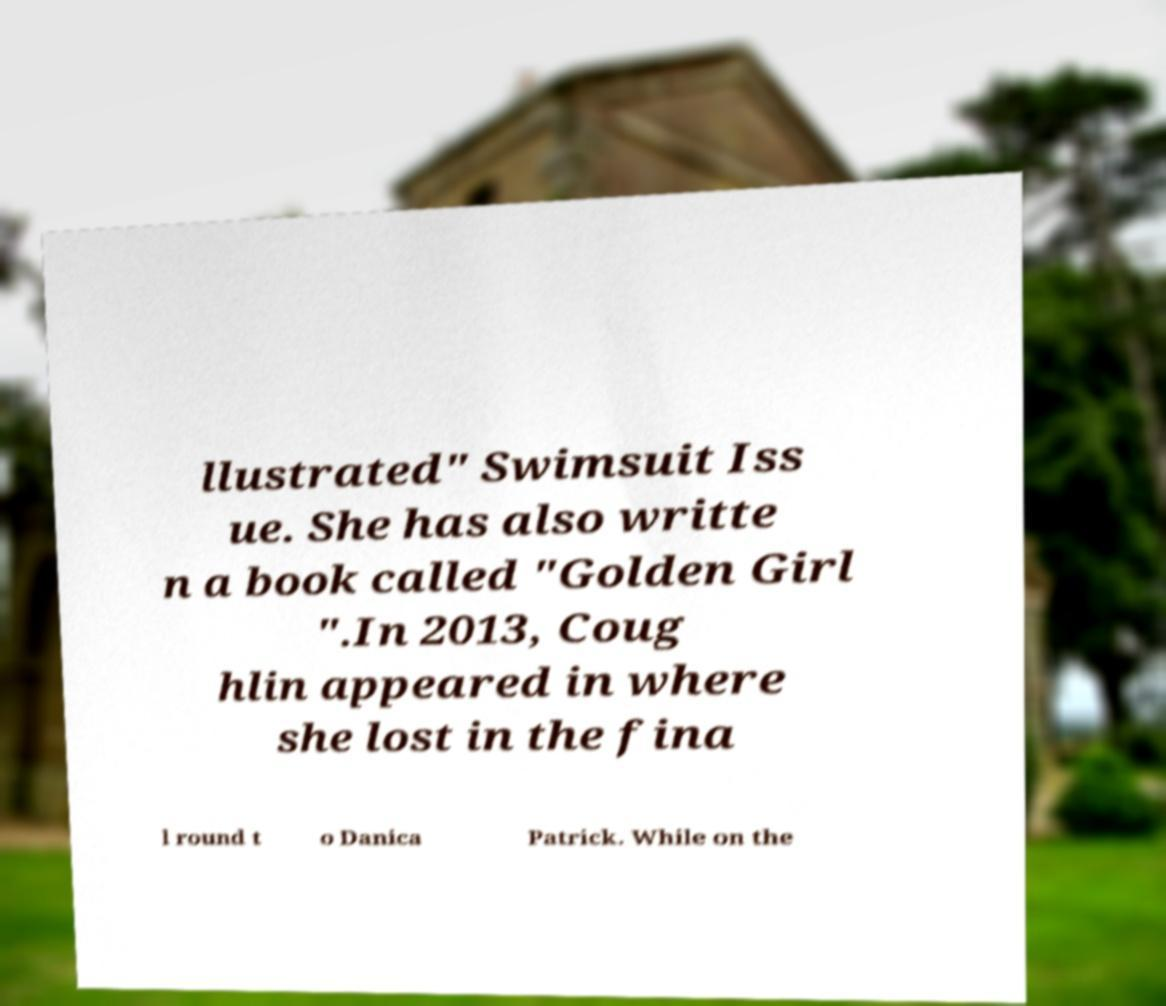Could you extract and type out the text from this image? llustrated" Swimsuit Iss ue. She has also writte n a book called "Golden Girl ".In 2013, Coug hlin appeared in where she lost in the fina l round t o Danica Patrick. While on the 